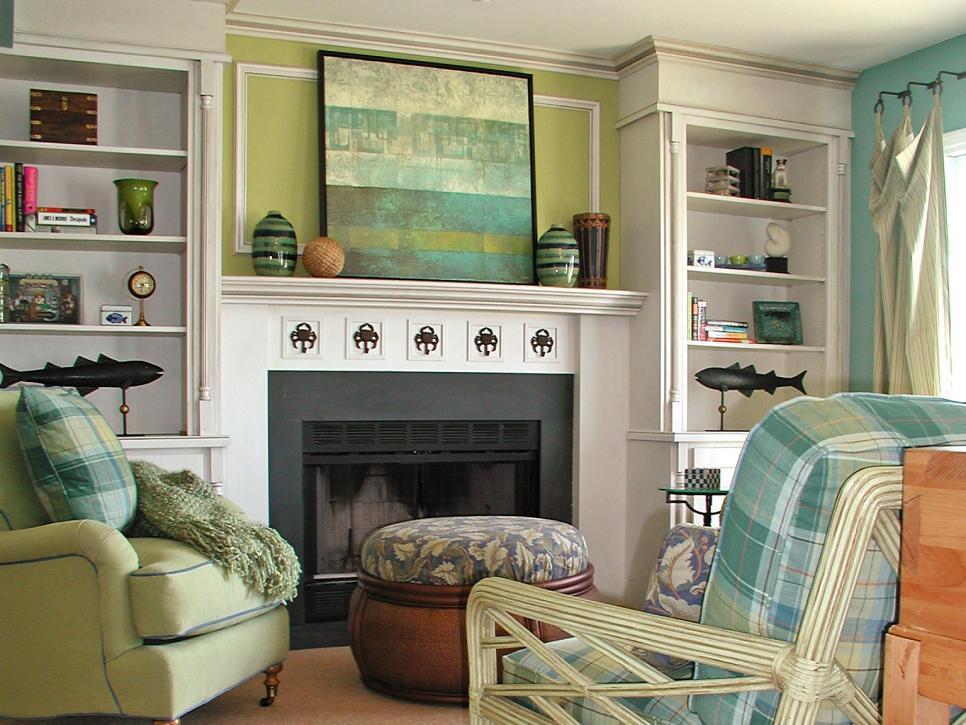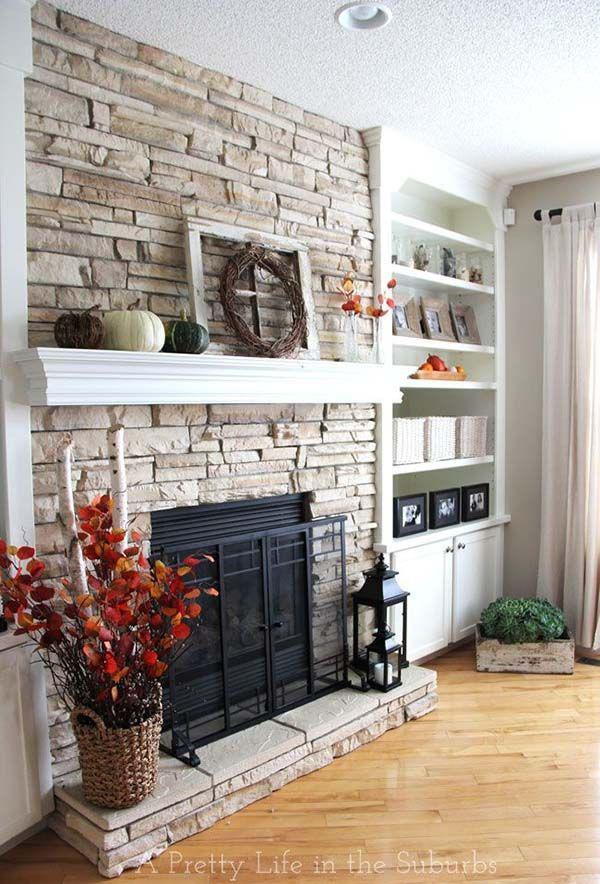The first image is the image on the left, the second image is the image on the right. Analyze the images presented: Is the assertion "One image shows white bookcases with arch shapes above the top shelves, flanking a fireplace that does not have a television mounted above it." valid? Answer yes or no. No. The first image is the image on the left, the second image is the image on the right. Considering the images on both sides, is "There are two chair with cream and blue pillows that match the the line painting on the mantle." valid? Answer yes or no. Yes. 